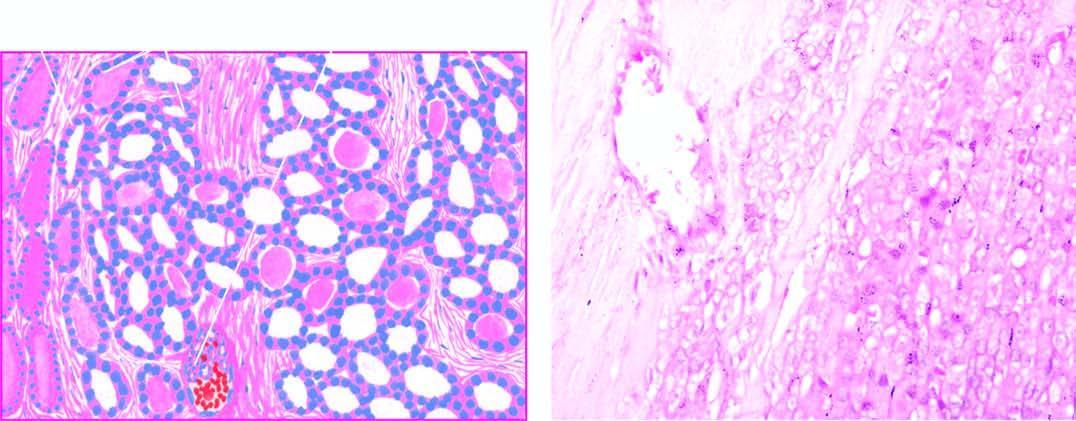what is there in the figure?
Answer the question using a single word or phrase. Mild pleomorphism 